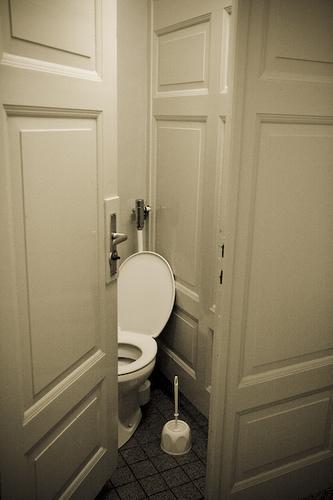How many boys are shown?
Give a very brief answer. 0. 